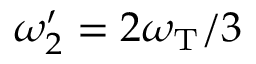Convert formula to latex. <formula><loc_0><loc_0><loc_500><loc_500>\omega _ { 2 } ^ { \prime } = 2 \omega _ { T } / 3</formula> 